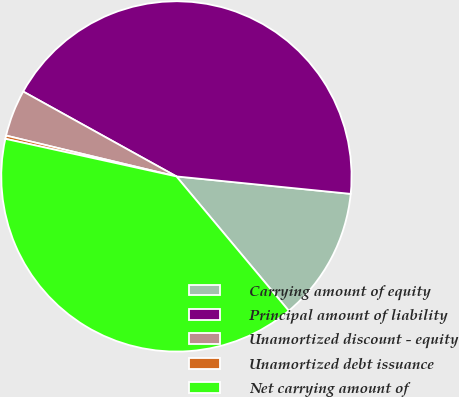Convert chart. <chart><loc_0><loc_0><loc_500><loc_500><pie_chart><fcel>Carrying amount of equity<fcel>Principal amount of liability<fcel>Unamortized discount - equity<fcel>Unamortized debt issuance<fcel>Net carrying amount of<nl><fcel>12.33%<fcel>43.54%<fcel>4.31%<fcel>0.3%<fcel>39.53%<nl></chart> 